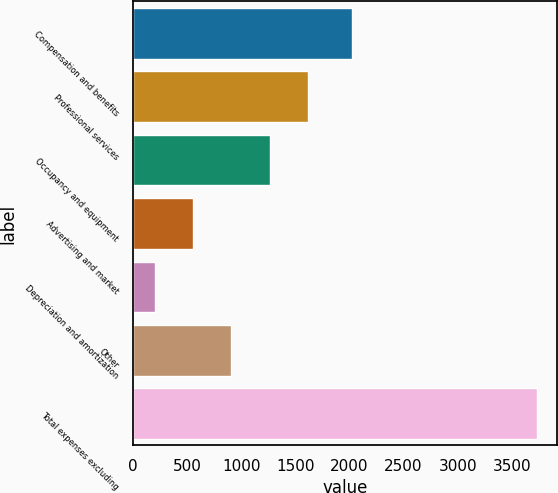Convert chart. <chart><loc_0><loc_0><loc_500><loc_500><bar_chart><fcel>Compensation and benefits<fcel>Professional services<fcel>Occupancy and equipment<fcel>Advertising and market<fcel>Depreciation and amortization<fcel>Other<fcel>Total expenses excluding<nl><fcel>2027<fcel>1613.2<fcel>1260.4<fcel>554.8<fcel>202<fcel>907.6<fcel>3730<nl></chart> 